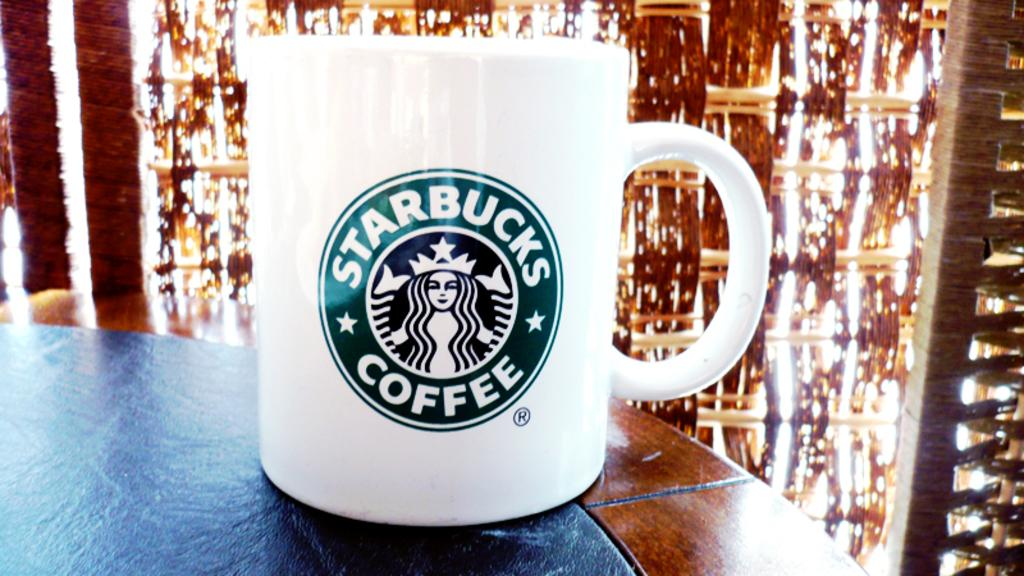<image>
Give a short and clear explanation of the subsequent image. White coffee cup with the words Starbucks coffee on it. 